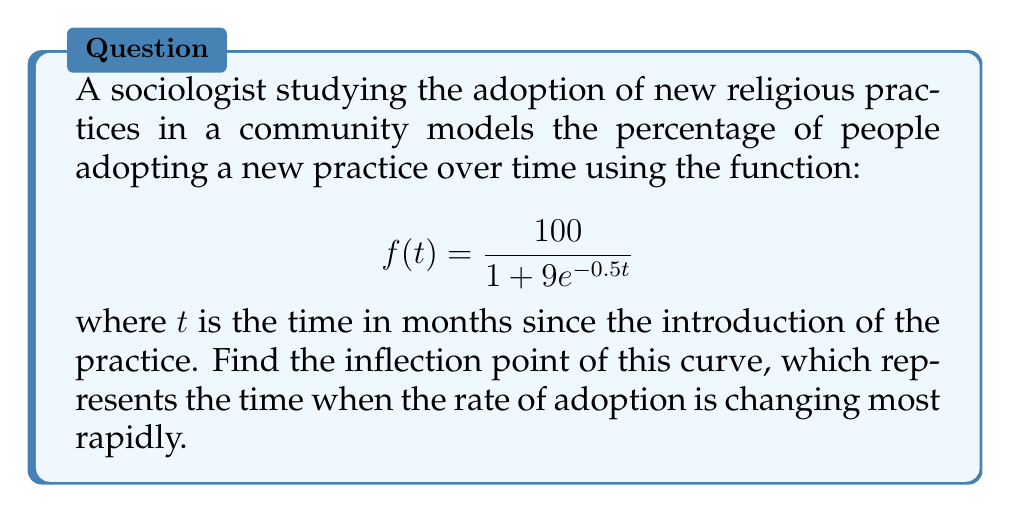Can you solve this math problem? To find the inflection point, we need to follow these steps:

1) First, calculate the first derivative $f'(t)$:
   $$f'(t) = \frac{100 \cdot 9 \cdot 0.5e^{-0.5t}}{(1 + 9e^{-0.5t})^2} = \frac{450e^{-0.5t}}{(1 + 9e^{-0.5t})^2}$$

2) Now, calculate the second derivative $f''(t)$:
   $$f''(t) = \frac{450e^{-0.5t} \cdot (-0.5)(1 + 9e^{-0.5t})^2 - 450e^{-0.5t} \cdot 2(1 + 9e^{-0.5t}) \cdot (-4.5e^{-0.5t})}{(1 + 9e^{-0.5t})^4}$$
   
   Simplifying:
   $$f''(t) = \frac{450e^{-0.5t}(-0.5 - 4.5e^{-0.5t} + 9e^{-0.5t})}{(1 + 9e^{-0.5t})^3} = \frac{450e^{-0.5t}(4.5e^{-0.5t} - 0.5)}{(1 + 9e^{-0.5t})^3}$$

3) The inflection point occurs where $f''(t) = 0$. Set the numerator to zero:
   $$450e^{-0.5t}(4.5e^{-0.5t} - 0.5) = 0$$

4) Solve this equation:
   $4.5e^{-0.5t} - 0.5 = 0$
   $4.5e^{-0.5t} = 0.5$
   $e^{-0.5t} = \frac{1}{9}$
   $-0.5t = \ln(\frac{1}{9}) = -\ln(9)$
   $t = 2\ln(9) \approx 4.39$

5) Verify that this is indeed an inflection point by checking that $f''(t)$ changes sign around this point.

Therefore, the inflection point occurs at approximately 4.39 months after the introduction of the new religious practice.
Answer: $t = 2\ln(9) \approx 4.39$ months 